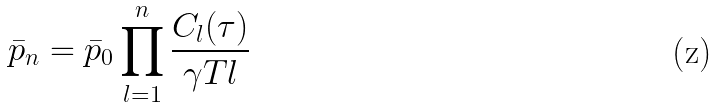<formula> <loc_0><loc_0><loc_500><loc_500>\bar { p } _ { n } = \bar { p } _ { 0 } \prod _ { l = 1 } ^ { n } \frac { C _ { l } ( \tau ) } { \gamma T l }</formula> 